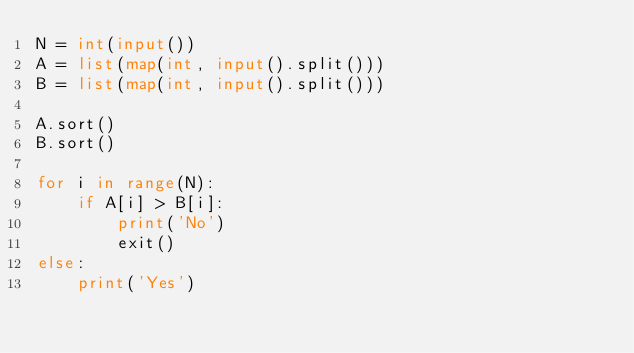Convert code to text. <code><loc_0><loc_0><loc_500><loc_500><_Python_>N = int(input())
A = list(map(int, input().split()))
B = list(map(int, input().split()))

A.sort()
B.sort()

for i in range(N):
    if A[i] > B[i]:
        print('No')
        exit()
else:
    print('Yes')</code> 